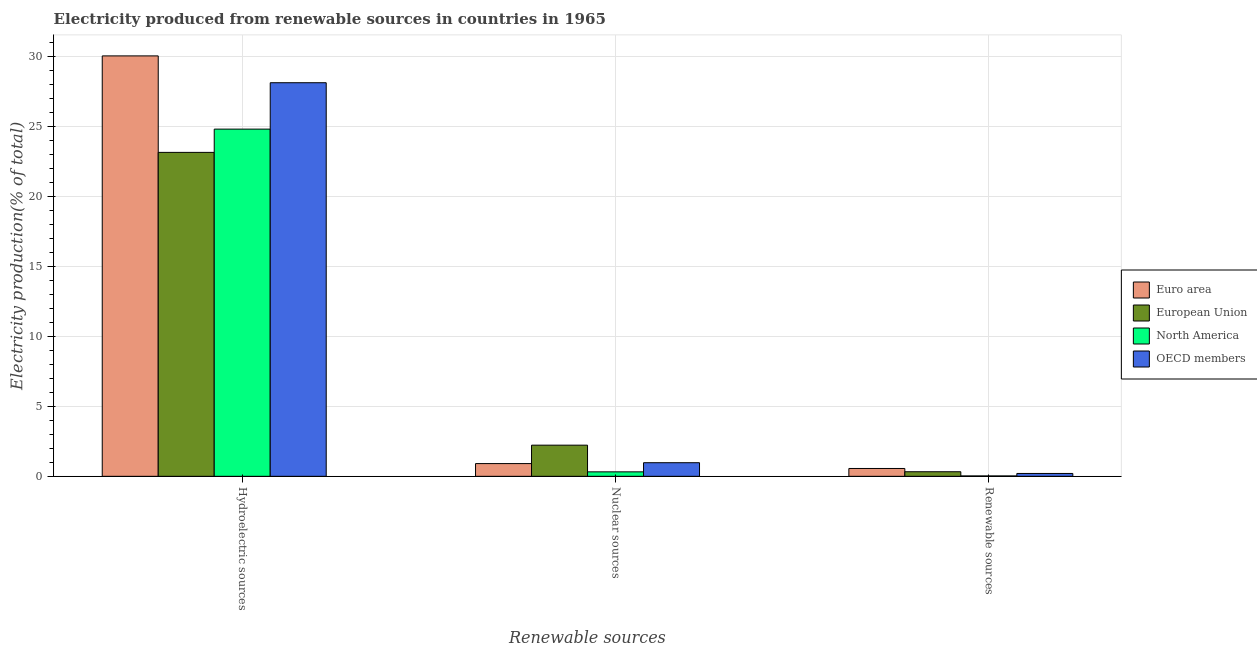How many different coloured bars are there?
Offer a very short reply. 4. Are the number of bars per tick equal to the number of legend labels?
Your answer should be compact. Yes. How many bars are there on the 3rd tick from the right?
Offer a very short reply. 4. What is the label of the 2nd group of bars from the left?
Your answer should be very brief. Nuclear sources. What is the percentage of electricity produced by hydroelectric sources in North America?
Your answer should be very brief. 24.81. Across all countries, what is the maximum percentage of electricity produced by hydroelectric sources?
Ensure brevity in your answer.  30.04. Across all countries, what is the minimum percentage of electricity produced by renewable sources?
Your answer should be very brief. 0.03. What is the total percentage of electricity produced by renewable sources in the graph?
Provide a short and direct response. 1.12. What is the difference between the percentage of electricity produced by nuclear sources in European Union and that in Euro area?
Provide a short and direct response. 1.32. What is the difference between the percentage of electricity produced by nuclear sources in European Union and the percentage of electricity produced by renewable sources in Euro area?
Offer a very short reply. 1.67. What is the average percentage of electricity produced by renewable sources per country?
Give a very brief answer. 0.28. What is the difference between the percentage of electricity produced by hydroelectric sources and percentage of electricity produced by renewable sources in European Union?
Offer a terse response. 22.82. What is the ratio of the percentage of electricity produced by nuclear sources in European Union to that in OECD members?
Offer a very short reply. 2.29. Is the percentage of electricity produced by hydroelectric sources in European Union less than that in Euro area?
Offer a very short reply. Yes. Is the difference between the percentage of electricity produced by renewable sources in North America and OECD members greater than the difference between the percentage of electricity produced by nuclear sources in North America and OECD members?
Offer a terse response. Yes. What is the difference between the highest and the second highest percentage of electricity produced by renewable sources?
Your answer should be compact. 0.23. What is the difference between the highest and the lowest percentage of electricity produced by renewable sources?
Provide a short and direct response. 0.53. How many bars are there?
Your answer should be compact. 12. What is the difference between two consecutive major ticks on the Y-axis?
Provide a short and direct response. 5. Does the graph contain grids?
Offer a very short reply. Yes. Where does the legend appear in the graph?
Your response must be concise. Center right. What is the title of the graph?
Provide a short and direct response. Electricity produced from renewable sources in countries in 1965. What is the label or title of the X-axis?
Offer a terse response. Renewable sources. What is the label or title of the Y-axis?
Keep it short and to the point. Electricity production(% of total). What is the Electricity production(% of total) in Euro area in Hydroelectric sources?
Your answer should be compact. 30.04. What is the Electricity production(% of total) of European Union in Hydroelectric sources?
Provide a succinct answer. 23.14. What is the Electricity production(% of total) of North America in Hydroelectric sources?
Your answer should be very brief. 24.81. What is the Electricity production(% of total) of OECD members in Hydroelectric sources?
Offer a terse response. 28.12. What is the Electricity production(% of total) in Euro area in Nuclear sources?
Offer a terse response. 0.91. What is the Electricity production(% of total) of European Union in Nuclear sources?
Keep it short and to the point. 2.23. What is the Electricity production(% of total) in North America in Nuclear sources?
Make the answer very short. 0.32. What is the Electricity production(% of total) of OECD members in Nuclear sources?
Provide a succinct answer. 0.97. What is the Electricity production(% of total) in Euro area in Renewable sources?
Offer a very short reply. 0.56. What is the Electricity production(% of total) in European Union in Renewable sources?
Your response must be concise. 0.33. What is the Electricity production(% of total) in North America in Renewable sources?
Your answer should be very brief. 0.03. What is the Electricity production(% of total) in OECD members in Renewable sources?
Provide a succinct answer. 0.2. Across all Renewable sources, what is the maximum Electricity production(% of total) in Euro area?
Your answer should be very brief. 30.04. Across all Renewable sources, what is the maximum Electricity production(% of total) in European Union?
Ensure brevity in your answer.  23.14. Across all Renewable sources, what is the maximum Electricity production(% of total) of North America?
Your response must be concise. 24.81. Across all Renewable sources, what is the maximum Electricity production(% of total) in OECD members?
Make the answer very short. 28.12. Across all Renewable sources, what is the minimum Electricity production(% of total) in Euro area?
Your response must be concise. 0.56. Across all Renewable sources, what is the minimum Electricity production(% of total) of European Union?
Keep it short and to the point. 0.33. Across all Renewable sources, what is the minimum Electricity production(% of total) of North America?
Ensure brevity in your answer.  0.03. Across all Renewable sources, what is the minimum Electricity production(% of total) in OECD members?
Your answer should be compact. 0.2. What is the total Electricity production(% of total) of Euro area in the graph?
Provide a succinct answer. 31.51. What is the total Electricity production(% of total) in European Union in the graph?
Ensure brevity in your answer.  25.7. What is the total Electricity production(% of total) in North America in the graph?
Keep it short and to the point. 25.15. What is the total Electricity production(% of total) in OECD members in the graph?
Make the answer very short. 29.3. What is the difference between the Electricity production(% of total) in Euro area in Hydroelectric sources and that in Nuclear sources?
Make the answer very short. 29.13. What is the difference between the Electricity production(% of total) of European Union in Hydroelectric sources and that in Nuclear sources?
Offer a terse response. 20.92. What is the difference between the Electricity production(% of total) of North America in Hydroelectric sources and that in Nuclear sources?
Make the answer very short. 24.49. What is the difference between the Electricity production(% of total) in OECD members in Hydroelectric sources and that in Nuclear sources?
Your answer should be compact. 27.15. What is the difference between the Electricity production(% of total) of Euro area in Hydroelectric sources and that in Renewable sources?
Ensure brevity in your answer.  29.48. What is the difference between the Electricity production(% of total) in European Union in Hydroelectric sources and that in Renewable sources?
Provide a short and direct response. 22.82. What is the difference between the Electricity production(% of total) in North America in Hydroelectric sources and that in Renewable sources?
Offer a very short reply. 24.78. What is the difference between the Electricity production(% of total) of OECD members in Hydroelectric sources and that in Renewable sources?
Give a very brief answer. 27.92. What is the difference between the Electricity production(% of total) in Euro area in Nuclear sources and that in Renewable sources?
Make the answer very short. 0.35. What is the difference between the Electricity production(% of total) in European Union in Nuclear sources and that in Renewable sources?
Provide a succinct answer. 1.9. What is the difference between the Electricity production(% of total) in North America in Nuclear sources and that in Renewable sources?
Provide a short and direct response. 0.29. What is the difference between the Electricity production(% of total) of OECD members in Nuclear sources and that in Renewable sources?
Keep it short and to the point. 0.77. What is the difference between the Electricity production(% of total) of Euro area in Hydroelectric sources and the Electricity production(% of total) of European Union in Nuclear sources?
Provide a short and direct response. 27.81. What is the difference between the Electricity production(% of total) in Euro area in Hydroelectric sources and the Electricity production(% of total) in North America in Nuclear sources?
Offer a terse response. 29.72. What is the difference between the Electricity production(% of total) of Euro area in Hydroelectric sources and the Electricity production(% of total) of OECD members in Nuclear sources?
Your response must be concise. 29.07. What is the difference between the Electricity production(% of total) in European Union in Hydroelectric sources and the Electricity production(% of total) in North America in Nuclear sources?
Your answer should be very brief. 22.83. What is the difference between the Electricity production(% of total) of European Union in Hydroelectric sources and the Electricity production(% of total) of OECD members in Nuclear sources?
Provide a succinct answer. 22.17. What is the difference between the Electricity production(% of total) of North America in Hydroelectric sources and the Electricity production(% of total) of OECD members in Nuclear sources?
Make the answer very short. 23.84. What is the difference between the Electricity production(% of total) in Euro area in Hydroelectric sources and the Electricity production(% of total) in European Union in Renewable sources?
Provide a succinct answer. 29.71. What is the difference between the Electricity production(% of total) in Euro area in Hydroelectric sources and the Electricity production(% of total) in North America in Renewable sources?
Provide a succinct answer. 30.01. What is the difference between the Electricity production(% of total) in Euro area in Hydroelectric sources and the Electricity production(% of total) in OECD members in Renewable sources?
Keep it short and to the point. 29.84. What is the difference between the Electricity production(% of total) in European Union in Hydroelectric sources and the Electricity production(% of total) in North America in Renewable sources?
Your response must be concise. 23.12. What is the difference between the Electricity production(% of total) of European Union in Hydroelectric sources and the Electricity production(% of total) of OECD members in Renewable sources?
Offer a terse response. 22.94. What is the difference between the Electricity production(% of total) of North America in Hydroelectric sources and the Electricity production(% of total) of OECD members in Renewable sources?
Your answer should be compact. 24.6. What is the difference between the Electricity production(% of total) of Euro area in Nuclear sources and the Electricity production(% of total) of European Union in Renewable sources?
Your response must be concise. 0.58. What is the difference between the Electricity production(% of total) in Euro area in Nuclear sources and the Electricity production(% of total) in North America in Renewable sources?
Provide a succinct answer. 0.88. What is the difference between the Electricity production(% of total) in Euro area in Nuclear sources and the Electricity production(% of total) in OECD members in Renewable sources?
Give a very brief answer. 0.71. What is the difference between the Electricity production(% of total) of European Union in Nuclear sources and the Electricity production(% of total) of North America in Renewable sources?
Your answer should be compact. 2.2. What is the difference between the Electricity production(% of total) of European Union in Nuclear sources and the Electricity production(% of total) of OECD members in Renewable sources?
Provide a succinct answer. 2.02. What is the difference between the Electricity production(% of total) in North America in Nuclear sources and the Electricity production(% of total) in OECD members in Renewable sources?
Provide a short and direct response. 0.12. What is the average Electricity production(% of total) of Euro area per Renewable sources?
Keep it short and to the point. 10.5. What is the average Electricity production(% of total) of European Union per Renewable sources?
Offer a very short reply. 8.57. What is the average Electricity production(% of total) of North America per Renewable sources?
Make the answer very short. 8.38. What is the average Electricity production(% of total) in OECD members per Renewable sources?
Offer a very short reply. 9.77. What is the difference between the Electricity production(% of total) of Euro area and Electricity production(% of total) of European Union in Hydroelectric sources?
Keep it short and to the point. 6.89. What is the difference between the Electricity production(% of total) of Euro area and Electricity production(% of total) of North America in Hydroelectric sources?
Your answer should be very brief. 5.23. What is the difference between the Electricity production(% of total) of Euro area and Electricity production(% of total) of OECD members in Hydroelectric sources?
Your answer should be very brief. 1.92. What is the difference between the Electricity production(% of total) in European Union and Electricity production(% of total) in North America in Hydroelectric sources?
Your response must be concise. -1.66. What is the difference between the Electricity production(% of total) in European Union and Electricity production(% of total) in OECD members in Hydroelectric sources?
Offer a very short reply. -4.98. What is the difference between the Electricity production(% of total) in North America and Electricity production(% of total) in OECD members in Hydroelectric sources?
Offer a terse response. -3.31. What is the difference between the Electricity production(% of total) of Euro area and Electricity production(% of total) of European Union in Nuclear sources?
Ensure brevity in your answer.  -1.32. What is the difference between the Electricity production(% of total) in Euro area and Electricity production(% of total) in North America in Nuclear sources?
Keep it short and to the point. 0.59. What is the difference between the Electricity production(% of total) in Euro area and Electricity production(% of total) in OECD members in Nuclear sources?
Make the answer very short. -0.06. What is the difference between the Electricity production(% of total) in European Union and Electricity production(% of total) in North America in Nuclear sources?
Your answer should be very brief. 1.91. What is the difference between the Electricity production(% of total) of European Union and Electricity production(% of total) of OECD members in Nuclear sources?
Offer a terse response. 1.25. What is the difference between the Electricity production(% of total) of North America and Electricity production(% of total) of OECD members in Nuclear sources?
Ensure brevity in your answer.  -0.65. What is the difference between the Electricity production(% of total) of Euro area and Electricity production(% of total) of European Union in Renewable sources?
Make the answer very short. 0.23. What is the difference between the Electricity production(% of total) of Euro area and Electricity production(% of total) of North America in Renewable sources?
Ensure brevity in your answer.  0.53. What is the difference between the Electricity production(% of total) in Euro area and Electricity production(% of total) in OECD members in Renewable sources?
Give a very brief answer. 0.36. What is the difference between the Electricity production(% of total) in European Union and Electricity production(% of total) in North America in Renewable sources?
Make the answer very short. 0.3. What is the difference between the Electricity production(% of total) in European Union and Electricity production(% of total) in OECD members in Renewable sources?
Provide a short and direct response. 0.12. What is the difference between the Electricity production(% of total) of North America and Electricity production(% of total) of OECD members in Renewable sources?
Offer a terse response. -0.18. What is the ratio of the Electricity production(% of total) of Euro area in Hydroelectric sources to that in Nuclear sources?
Provide a succinct answer. 33.03. What is the ratio of the Electricity production(% of total) of European Union in Hydroelectric sources to that in Nuclear sources?
Your response must be concise. 10.4. What is the ratio of the Electricity production(% of total) of North America in Hydroelectric sources to that in Nuclear sources?
Ensure brevity in your answer.  77.71. What is the ratio of the Electricity production(% of total) in OECD members in Hydroelectric sources to that in Nuclear sources?
Provide a short and direct response. 28.91. What is the ratio of the Electricity production(% of total) in Euro area in Hydroelectric sources to that in Renewable sources?
Provide a succinct answer. 53.62. What is the ratio of the Electricity production(% of total) of European Union in Hydroelectric sources to that in Renewable sources?
Your answer should be compact. 70.88. What is the ratio of the Electricity production(% of total) in North America in Hydroelectric sources to that in Renewable sources?
Give a very brief answer. 910.23. What is the ratio of the Electricity production(% of total) of OECD members in Hydroelectric sources to that in Renewable sources?
Give a very brief answer. 138.1. What is the ratio of the Electricity production(% of total) of Euro area in Nuclear sources to that in Renewable sources?
Your response must be concise. 1.62. What is the ratio of the Electricity production(% of total) in European Union in Nuclear sources to that in Renewable sources?
Offer a very short reply. 6.82. What is the ratio of the Electricity production(% of total) in North America in Nuclear sources to that in Renewable sources?
Keep it short and to the point. 11.71. What is the ratio of the Electricity production(% of total) of OECD members in Nuclear sources to that in Renewable sources?
Provide a succinct answer. 4.78. What is the difference between the highest and the second highest Electricity production(% of total) of Euro area?
Ensure brevity in your answer.  29.13. What is the difference between the highest and the second highest Electricity production(% of total) of European Union?
Your response must be concise. 20.92. What is the difference between the highest and the second highest Electricity production(% of total) of North America?
Give a very brief answer. 24.49. What is the difference between the highest and the second highest Electricity production(% of total) in OECD members?
Offer a very short reply. 27.15. What is the difference between the highest and the lowest Electricity production(% of total) in Euro area?
Your answer should be very brief. 29.48. What is the difference between the highest and the lowest Electricity production(% of total) of European Union?
Your answer should be very brief. 22.82. What is the difference between the highest and the lowest Electricity production(% of total) in North America?
Give a very brief answer. 24.78. What is the difference between the highest and the lowest Electricity production(% of total) in OECD members?
Your response must be concise. 27.92. 